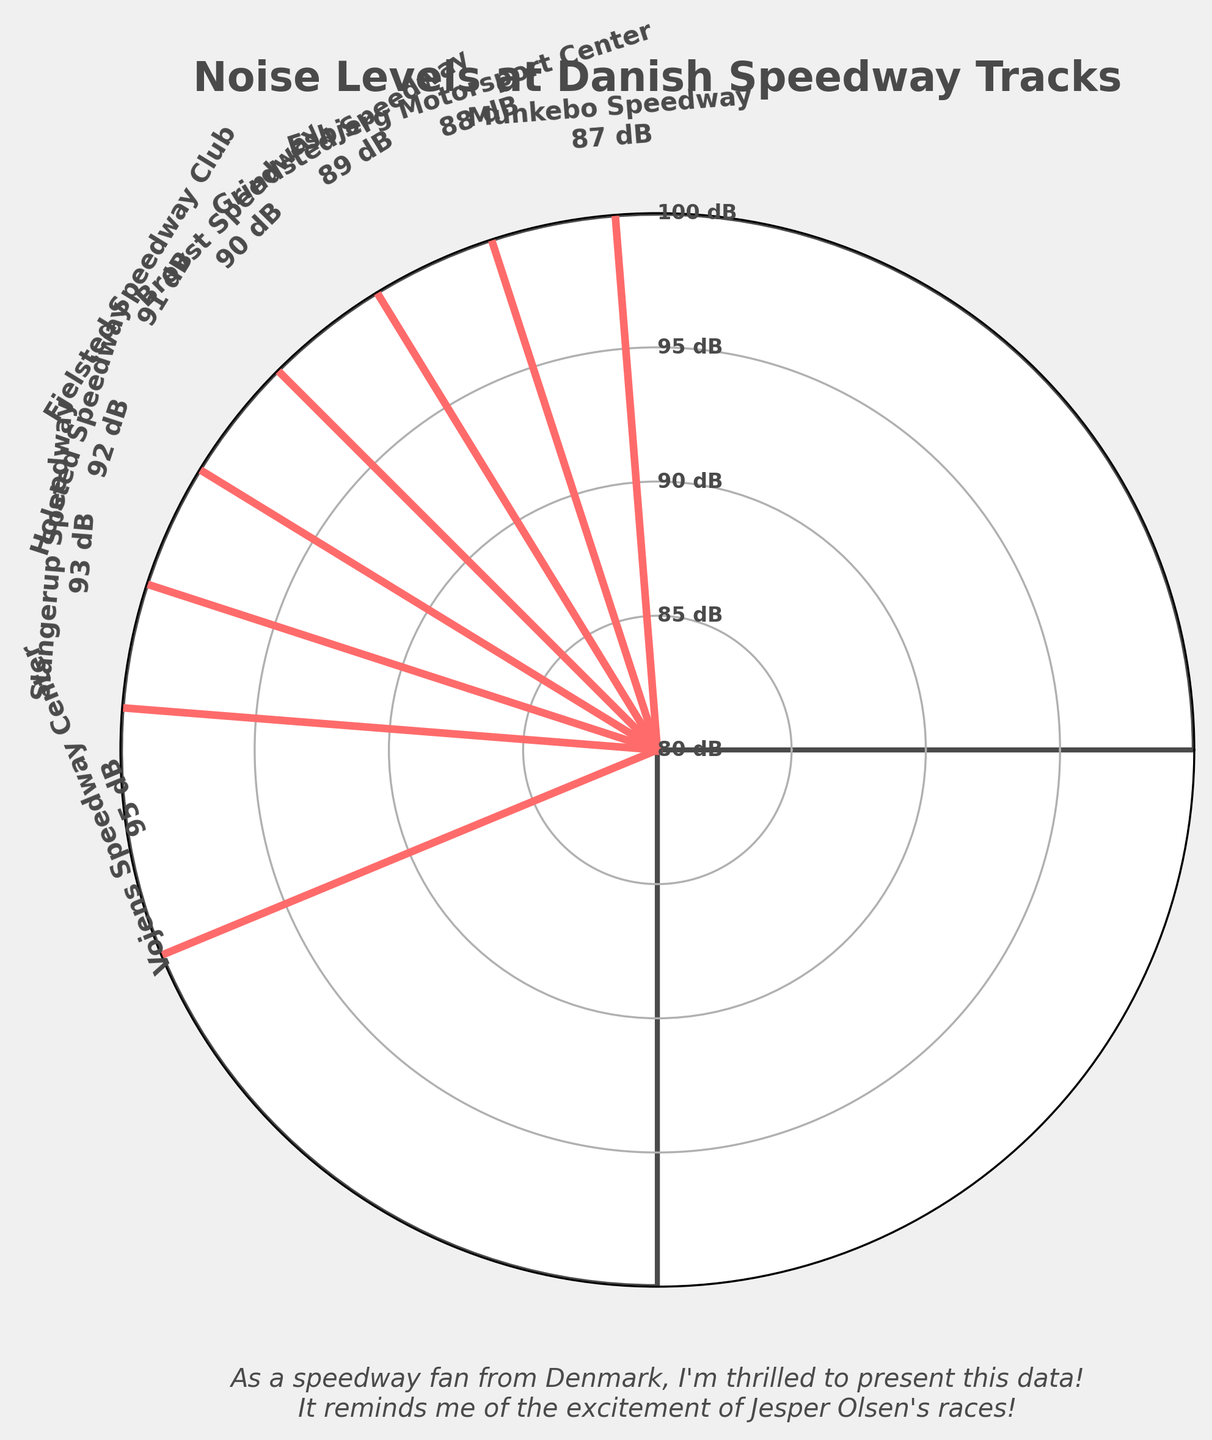What is the title of the figure? The title is located at the top of the figure and is clear and bold. It reads "Noise Levels at Danish Speedway Tracks."
Answer: Noise Levels at Danish Speedway Tracks How many speedway tracks are represented in the figure? Count the number of different tracks labeled around the gauge. Each track has a specific noise level displayed with its name. There are 8 tracks.
Answer: 8 Which speedway track has the highest noise level? Look at the noise levels given next to each track. The track with the highest dB is identified. "Vojens Speedway Center" has a noise level of 95 dB.
Answer: Vojens Speedway Center What's the noise level at Grindsted Speedway? Find the label for "Grindsted Speedway" around the gauge. It indicates a noise level of 89 dB.
Answer: 89 dB Which speedway track has a noise level of 92 dB? Locate the noise levels on the figure and check which track is labeled with 92 dB. It is "Holsted Speedway."
Answer: Holsted Speedway How much higher is the noise level at Slangerup Speedway compared to Esbjerg Motorsport Center? Find the noise levels for both Slangerup (93 dB) and Esbjerg (88 dB) tracks and subtract them (93 - 88).
Answer: 5 dB Which speedway track has a lower noise level, Munkebo Speedway or Brovst Speedway? Compare the noise levels of Munkebo (87 dB) and Brovst (90 dB). Munkebo has a lower noise level.
Answer: Munkebo Speedway What is the average noise level across all the speedway tracks? Add all the noise levels (95 + 92 + 88 + 91 + 89 + 93 + 87 + 90 = 725) and divide by the number of tracks (8).
Answer: 90.625 dB Are there more tracks above or below 90 dB? Count the tracks with noise levels above and below 90 dB: Above (Vojens, Slangerup, Holsted, Fjelsted) = 4; Below (Esbjerg, Grindsted, Munkebo, Brovst) = 4. The number is equal.
Answer: Equal Which speedway track's noise level is closest to the median noise level of all tracks? List the noise levels (87, 88, 89, 90, 91, 92, 93, 95), the median is between the 4th and 5th values (90 and 91). Brovst (90 dB) and Fjelsted (91 dB) are closest.
Answer: Brovst Speedway and Fjelsted Speedway 